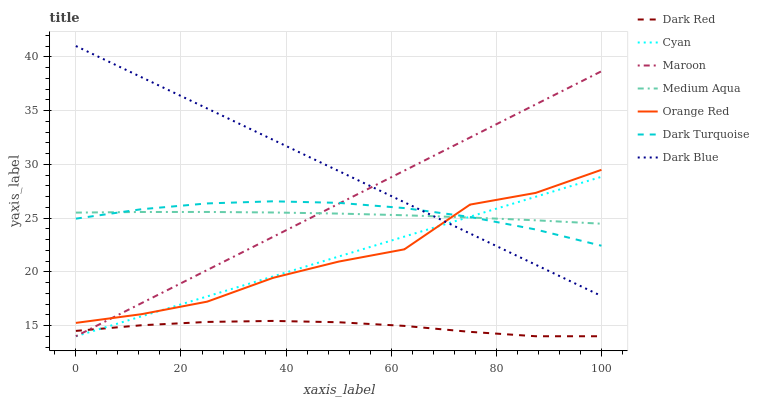Does Dark Red have the minimum area under the curve?
Answer yes or no. Yes. Does Dark Blue have the maximum area under the curve?
Answer yes or no. Yes. Does Maroon have the minimum area under the curve?
Answer yes or no. No. Does Maroon have the maximum area under the curve?
Answer yes or no. No. Is Maroon the smoothest?
Answer yes or no. Yes. Is Orange Red the roughest?
Answer yes or no. Yes. Is Dark Blue the smoothest?
Answer yes or no. No. Is Dark Blue the roughest?
Answer yes or no. No. Does Dark Red have the lowest value?
Answer yes or no. Yes. Does Dark Blue have the lowest value?
Answer yes or no. No. Does Dark Blue have the highest value?
Answer yes or no. Yes. Does Maroon have the highest value?
Answer yes or no. No. Is Dark Red less than Orange Red?
Answer yes or no. Yes. Is Dark Turquoise greater than Dark Red?
Answer yes or no. Yes. Does Dark Turquoise intersect Orange Red?
Answer yes or no. Yes. Is Dark Turquoise less than Orange Red?
Answer yes or no. No. Is Dark Turquoise greater than Orange Red?
Answer yes or no. No. Does Dark Red intersect Orange Red?
Answer yes or no. No. 